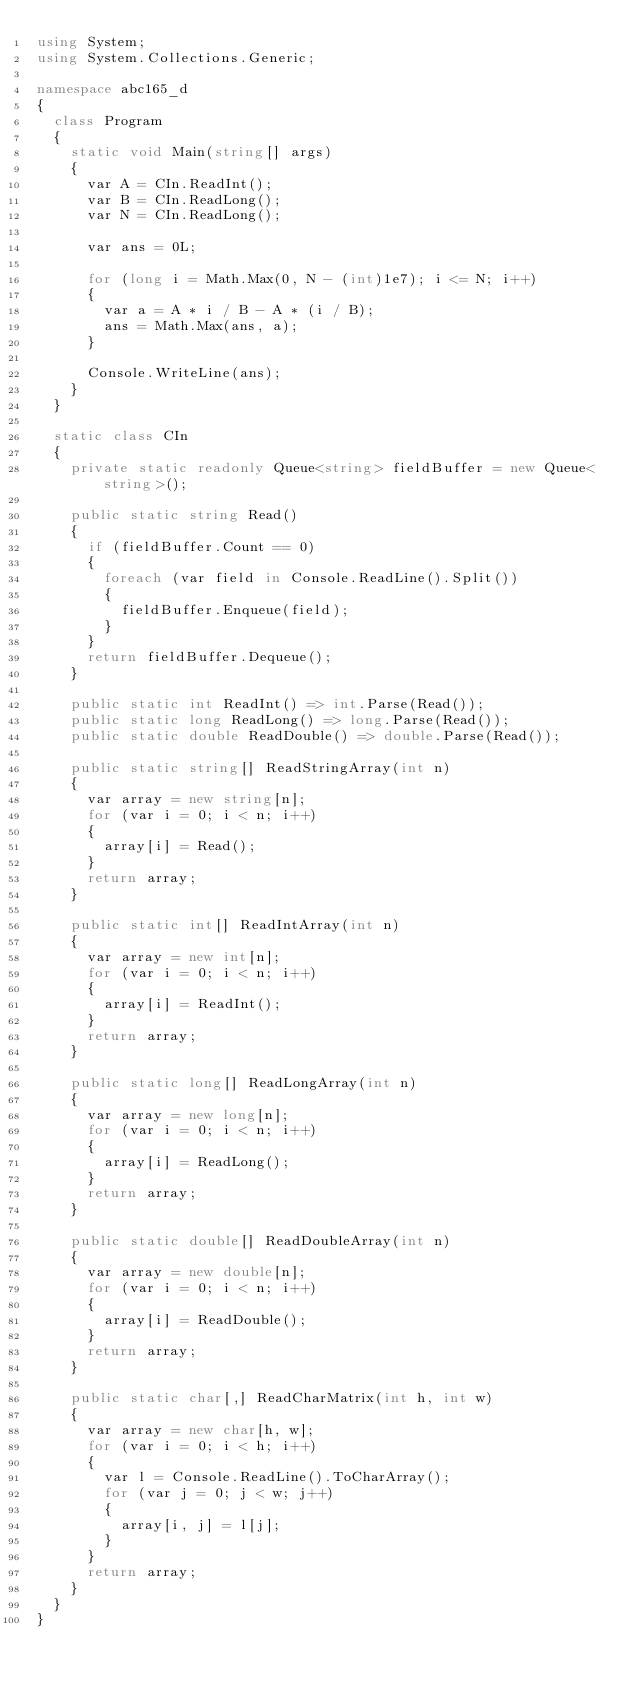Convert code to text. <code><loc_0><loc_0><loc_500><loc_500><_C#_>using System;
using System.Collections.Generic;

namespace abc165_d
{
  class Program
  {
    static void Main(string[] args)
    {
      var A = CIn.ReadInt();
      var B = CIn.ReadLong();
      var N = CIn.ReadLong();

      var ans = 0L;

      for (long i = Math.Max(0, N - (int)1e7); i <= N; i++)
      {
        var a = A * i / B - A * (i / B);
        ans = Math.Max(ans, a);
      }

      Console.WriteLine(ans);
    }
  }

  static class CIn
  {
    private static readonly Queue<string> fieldBuffer = new Queue<string>();

    public static string Read()
    {
      if (fieldBuffer.Count == 0)
      {
        foreach (var field in Console.ReadLine().Split())
        {
          fieldBuffer.Enqueue(field);
        }
      }
      return fieldBuffer.Dequeue();
    }

    public static int ReadInt() => int.Parse(Read());
    public static long ReadLong() => long.Parse(Read());
    public static double ReadDouble() => double.Parse(Read());

    public static string[] ReadStringArray(int n)
    {
      var array = new string[n];
      for (var i = 0; i < n; i++)
      {
        array[i] = Read();
      }
      return array;
    }

    public static int[] ReadIntArray(int n)
    {
      var array = new int[n];
      for (var i = 0; i < n; i++)
      {
        array[i] = ReadInt();
      }
      return array;
    }

    public static long[] ReadLongArray(int n)
    {
      var array = new long[n];
      for (var i = 0; i < n; i++)
      {
        array[i] = ReadLong();
      }
      return array;
    }

    public static double[] ReadDoubleArray(int n)
    {
      var array = new double[n];
      for (var i = 0; i < n; i++)
      {
        array[i] = ReadDouble();
      }
      return array;
    }

    public static char[,] ReadCharMatrix(int h, int w)
    {
      var array = new char[h, w];
      for (var i = 0; i < h; i++)
      {
        var l = Console.ReadLine().ToCharArray();
        for (var j = 0; j < w; j++)
        {
          array[i, j] = l[j];
        }
      }
      return array;
    }
  }
}
</code> 